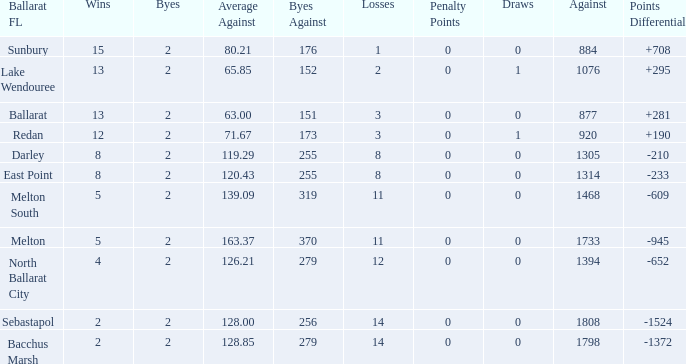How many Against has a Ballarat FL of darley and Wins larger than 8? 0.0. 